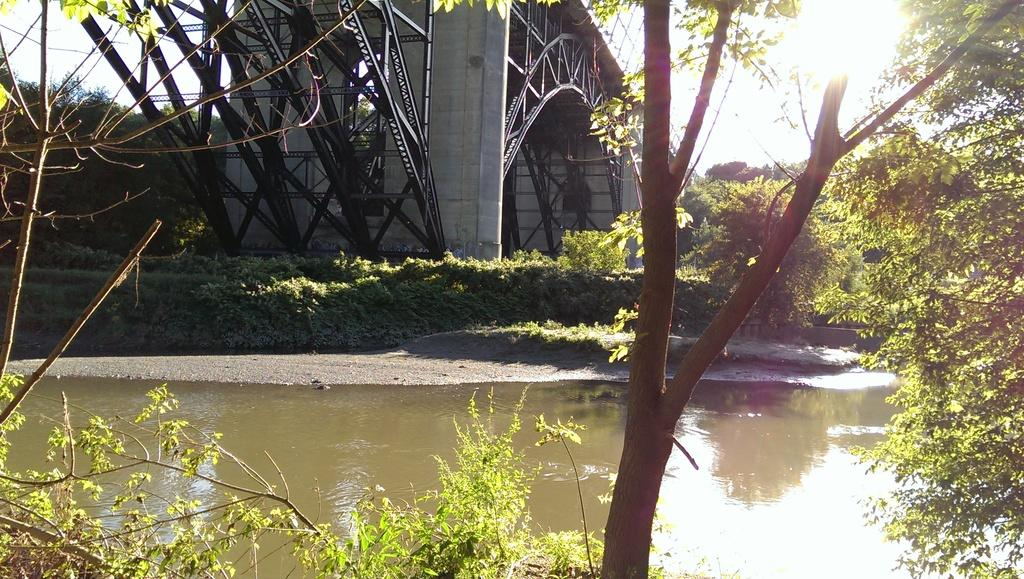What type of natural environment is depicted in the image? The image features many trees, suggesting a forest or wooded area. What can be seen besides the trees in the image? There is water visible in the image, as well as a bridge in the back. What is visible in the sky in the image? The sky is visible in the image, but no specific details about the sky are mentioned in the facts. How many elements can be seen in the image? There are at least four elements visible: trees, water, a bridge, and the sky. How many passengers are on the frog in the image? There is no frog or passengers present in the image. What type of channel can be seen in the image? There is no channel visible in the image; it features trees, water, a bridge, and the sky. 